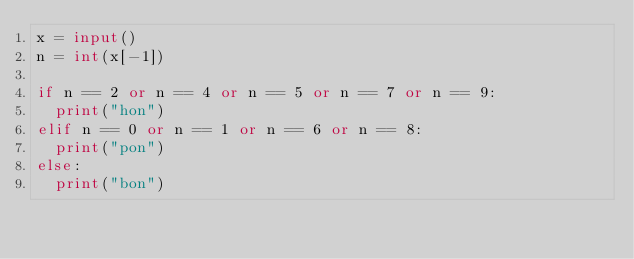<code> <loc_0><loc_0><loc_500><loc_500><_Python_>x = input()
n = int(x[-1])

if n == 2 or n == 4 or n == 5 or n == 7 or n == 9:
  print("hon")
elif n == 0 or n == 1 or n == 6 or n == 8:
  print("pon")
else:
  print("bon")</code> 